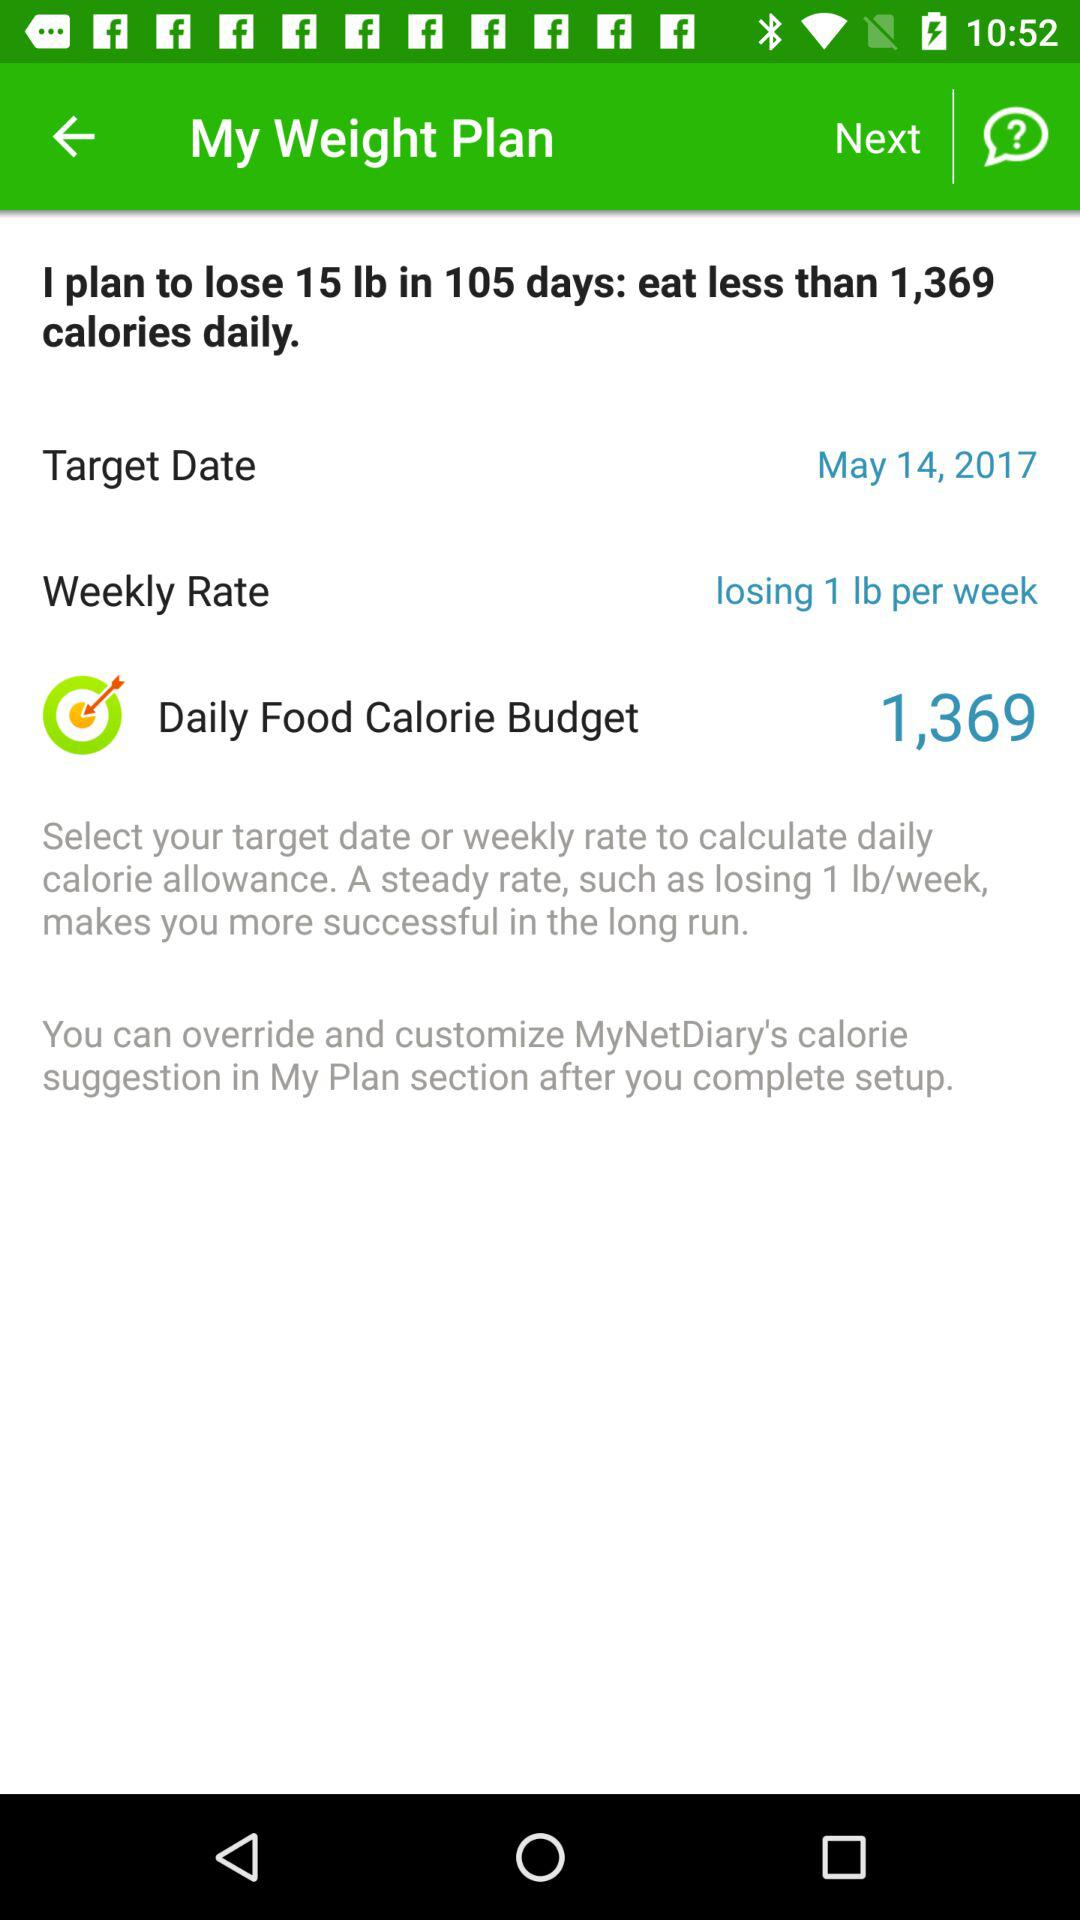How many pounds do I plan to lose in 105 days? You plan to lose 15 pounds in 105 days. 